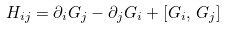Convert formula to latex. <formula><loc_0><loc_0><loc_500><loc_500>H _ { i j } = \partial _ { i } G _ { j } - \partial _ { j } G _ { i } + [ G _ { i } , \, G _ { j } ]</formula> 